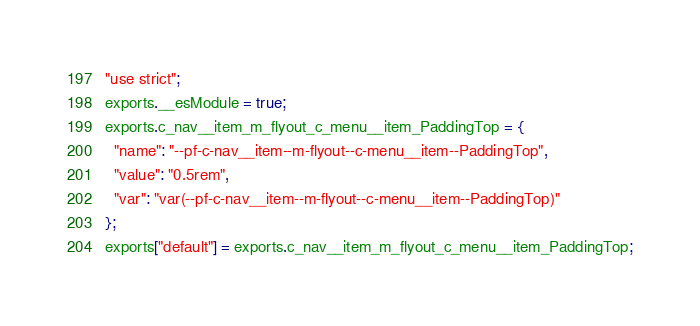Convert code to text. <code><loc_0><loc_0><loc_500><loc_500><_JavaScript_>"use strict";
exports.__esModule = true;
exports.c_nav__item_m_flyout_c_menu__item_PaddingTop = {
  "name": "--pf-c-nav__item--m-flyout--c-menu__item--PaddingTop",
  "value": "0.5rem",
  "var": "var(--pf-c-nav__item--m-flyout--c-menu__item--PaddingTop)"
};
exports["default"] = exports.c_nav__item_m_flyout_c_menu__item_PaddingTop;</code> 